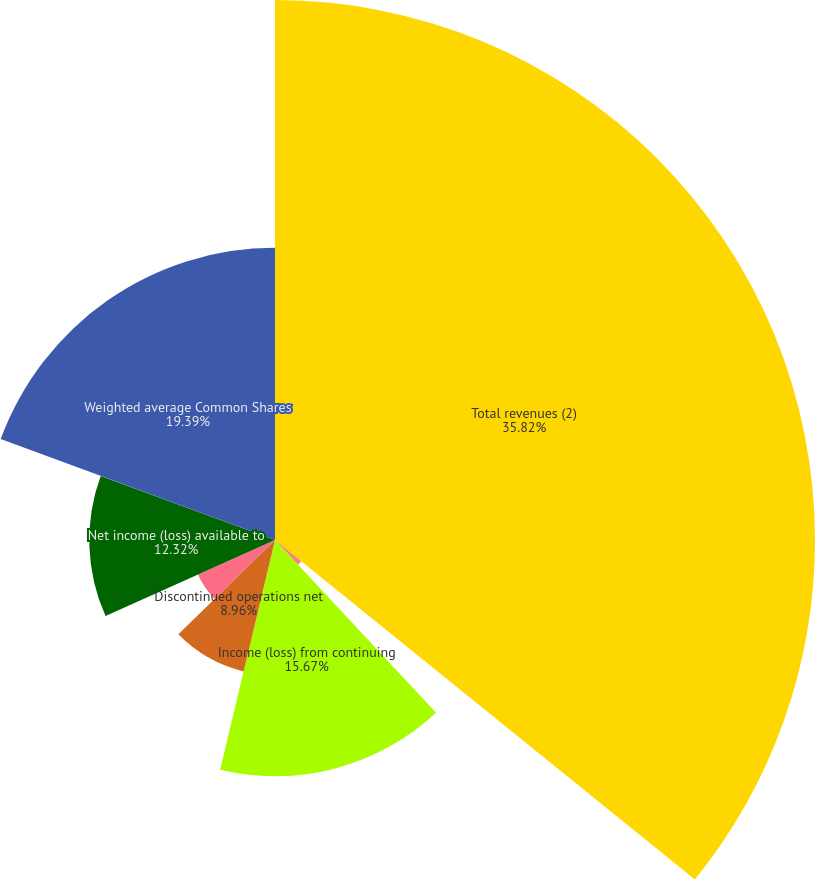<chart> <loc_0><loc_0><loc_500><loc_500><pie_chart><fcel>Total revenues (2)<fcel>Operating income (2)<fcel>Income (loss) from continuing<fcel>Discontinued operations net<fcel>Net income (loss)<fcel>Net income (loss) available to<fcel>Weighted average Common Shares<nl><fcel>35.82%<fcel>2.24%<fcel>15.67%<fcel>8.96%<fcel>5.6%<fcel>12.32%<fcel>19.39%<nl></chart> 